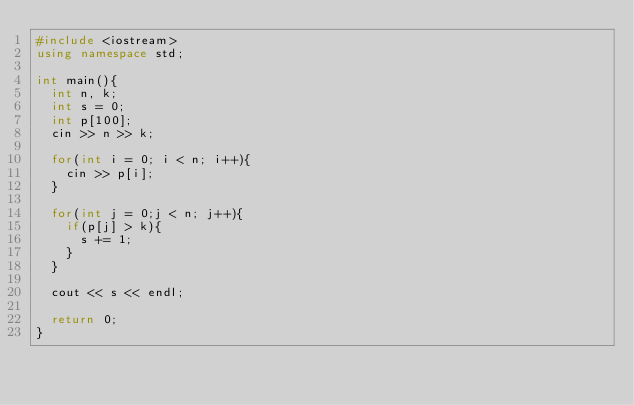Convert code to text. <code><loc_0><loc_0><loc_500><loc_500><_C++_>#include <iostream>
using namespace std;

int main(){
  int n, k;
  int s = 0;
  int p[100];
  cin >> n >> k;

  for(int i = 0; i < n; i++){
    cin >> p[i];
  }

  for(int j = 0;j < n; j++){
    if(p[j] > k){
      s += 1;
    }
  }

  cout << s << endl;

  return 0;
}</code> 